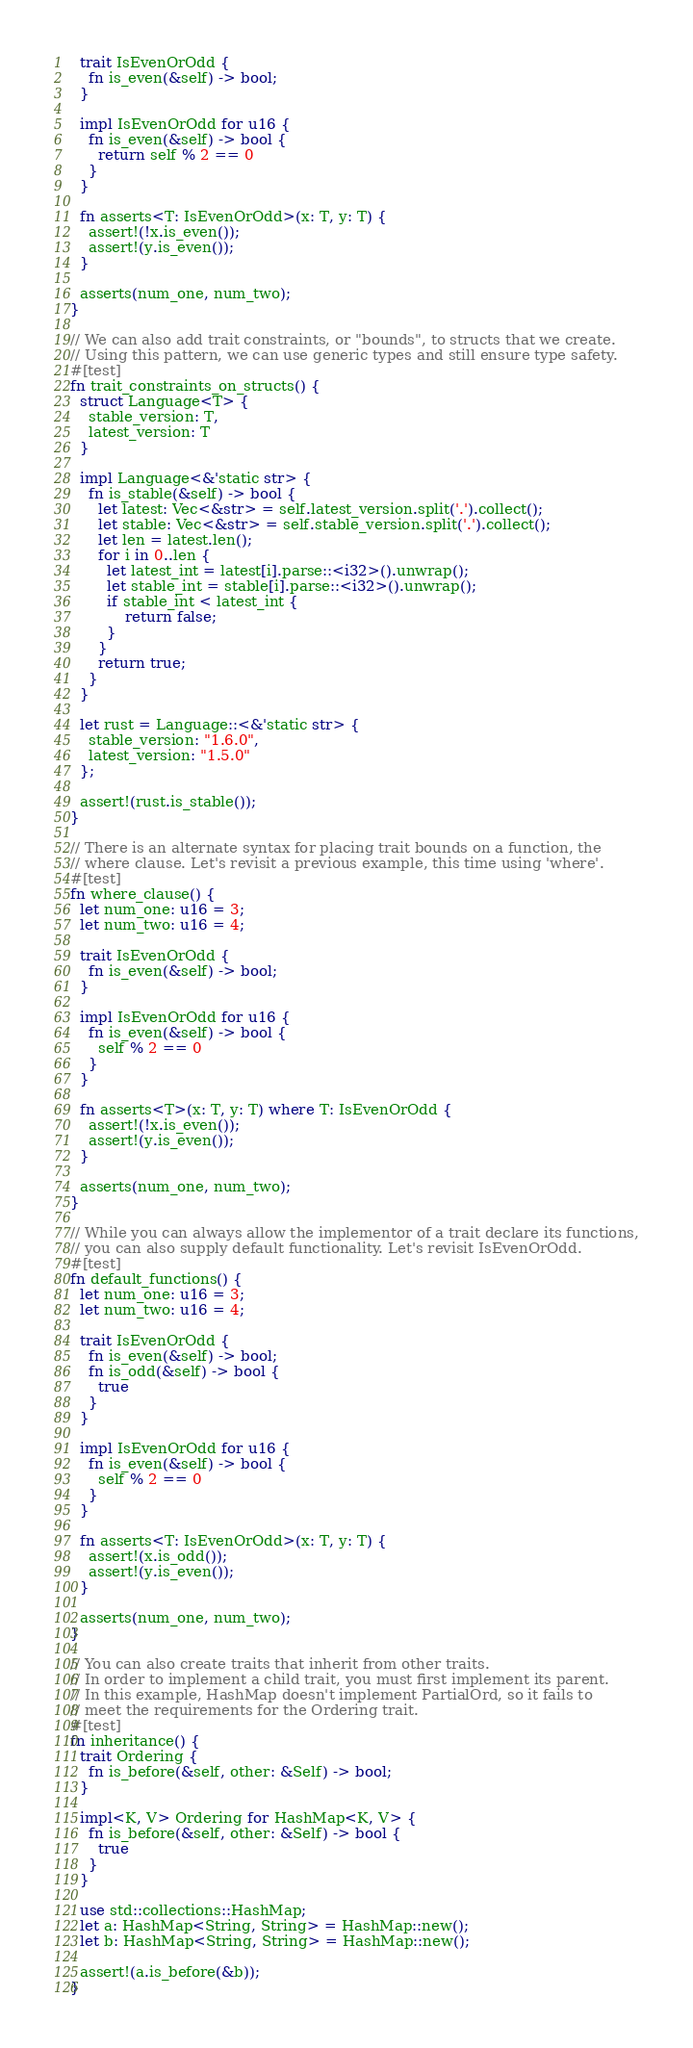<code> <loc_0><loc_0><loc_500><loc_500><_Rust_>
  trait IsEvenOrOdd {
    fn is_even(&self) -> bool;
  }

  impl IsEvenOrOdd for u16 {
    fn is_even(&self) -> bool {
      return self % 2 == 0
    }
  }

  fn asserts<T: IsEvenOrOdd>(x: T, y: T) {
    assert!(!x.is_even());
    assert!(y.is_even());
  }

  asserts(num_one, num_two);
}

// We can also add trait constraints, or "bounds", to structs that we create.
// Using this pattern, we can use generic types and still ensure type safety.
#[test]
fn trait_constraints_on_structs() {
  struct Language<T> {
    stable_version: T,
    latest_version: T
  }

  impl Language<&'static str> {
    fn is_stable(&self) -> bool {
      let latest: Vec<&str> = self.latest_version.split('.').collect();
      let stable: Vec<&str> = self.stable_version.split('.').collect();
      let len = latest.len();
      for i in 0..len {
        let latest_int = latest[i].parse::<i32>().unwrap();
        let stable_int = stable[i].parse::<i32>().unwrap();
        if stable_int < latest_int {
            return false;
        }
      }
      return true;
    }
  }

  let rust = Language::<&'static str> {
    stable_version: "1.6.0",
    latest_version: "1.5.0"
  };

  assert!(rust.is_stable());
}

// There is an alternate syntax for placing trait bounds on a function, the
// where clause. Let's revisit a previous example, this time using 'where'.
#[test]
fn where_clause() {
  let num_one: u16 = 3;
  let num_two: u16 = 4;

  trait IsEvenOrOdd {
    fn is_even(&self) -> bool;
  }

  impl IsEvenOrOdd for u16 {
    fn is_even(&self) -> bool {
      self % 2 == 0
    }
  }

  fn asserts<T>(x: T, y: T) where T: IsEvenOrOdd {
    assert!(!x.is_even());
    assert!(y.is_even());
  }

  asserts(num_one, num_two);
}

// While you can always allow the implementor of a trait declare its functions,
// you can also supply default functionality. Let's revisit IsEvenOrOdd.
#[test]
fn default_functions() {
  let num_one: u16 = 3;
  let num_two: u16 = 4;

  trait IsEvenOrOdd {
    fn is_even(&self) -> bool;
    fn is_odd(&self) -> bool {
      true
    }
  }

  impl IsEvenOrOdd for u16 {
    fn is_even(&self) -> bool {
      self % 2 == 0
    }
  }

  fn asserts<T: IsEvenOrOdd>(x: T, y: T) {
    assert!(x.is_odd());
    assert!(y.is_even());
  }

  asserts(num_one, num_two);
}

// You can also create traits that inherit from other traits.
// In order to implement a child trait, you must first implement its parent.
// In this example, HashMap doesn't implement PartialOrd, so it fails to
// meet the requirements for the Ordering trait.
#[test]
fn inheritance() {
  trait Ordering {
    fn is_before(&self, other: &Self) -> bool;
  }

  impl<K, V> Ordering for HashMap<K, V> {
    fn is_before(&self, other: &Self) -> bool {
      true
    }
  }

  use std::collections::HashMap;
  let a: HashMap<String, String> = HashMap::new();
  let b: HashMap<String, String> = HashMap::new();

  assert!(a.is_before(&b));
}
</code> 